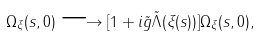Convert formula to latex. <formula><loc_0><loc_0><loc_500><loc_500>\Omega _ { \xi } ( s , 0 ) \longrightarrow [ 1 + i \tilde { g } \tilde { \Lambda } ( \xi ( s ) ) ] \Omega _ { \xi } ( s , 0 ) ,</formula> 